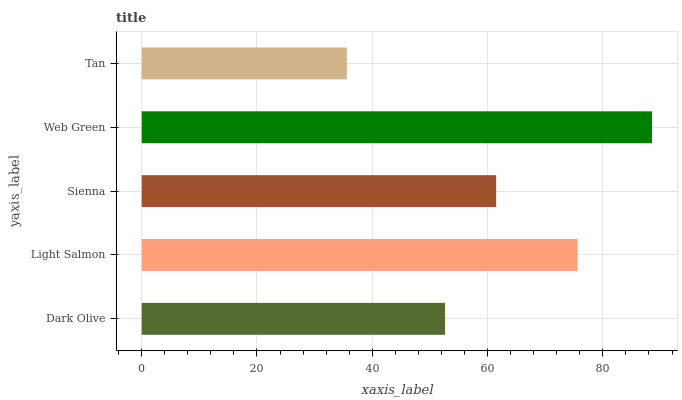Is Tan the minimum?
Answer yes or no. Yes. Is Web Green the maximum?
Answer yes or no. Yes. Is Light Salmon the minimum?
Answer yes or no. No. Is Light Salmon the maximum?
Answer yes or no. No. Is Light Salmon greater than Dark Olive?
Answer yes or no. Yes. Is Dark Olive less than Light Salmon?
Answer yes or no. Yes. Is Dark Olive greater than Light Salmon?
Answer yes or no. No. Is Light Salmon less than Dark Olive?
Answer yes or no. No. Is Sienna the high median?
Answer yes or no. Yes. Is Sienna the low median?
Answer yes or no. Yes. Is Web Green the high median?
Answer yes or no. No. Is Web Green the low median?
Answer yes or no. No. 